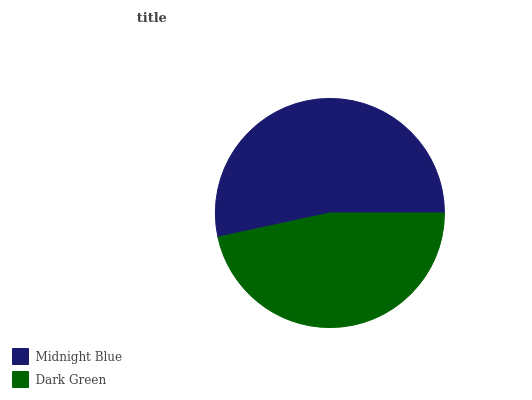Is Dark Green the minimum?
Answer yes or no. Yes. Is Midnight Blue the maximum?
Answer yes or no. Yes. Is Dark Green the maximum?
Answer yes or no. No. Is Midnight Blue greater than Dark Green?
Answer yes or no. Yes. Is Dark Green less than Midnight Blue?
Answer yes or no. Yes. Is Dark Green greater than Midnight Blue?
Answer yes or no. No. Is Midnight Blue less than Dark Green?
Answer yes or no. No. Is Midnight Blue the high median?
Answer yes or no. Yes. Is Dark Green the low median?
Answer yes or no. Yes. Is Dark Green the high median?
Answer yes or no. No. Is Midnight Blue the low median?
Answer yes or no. No. 